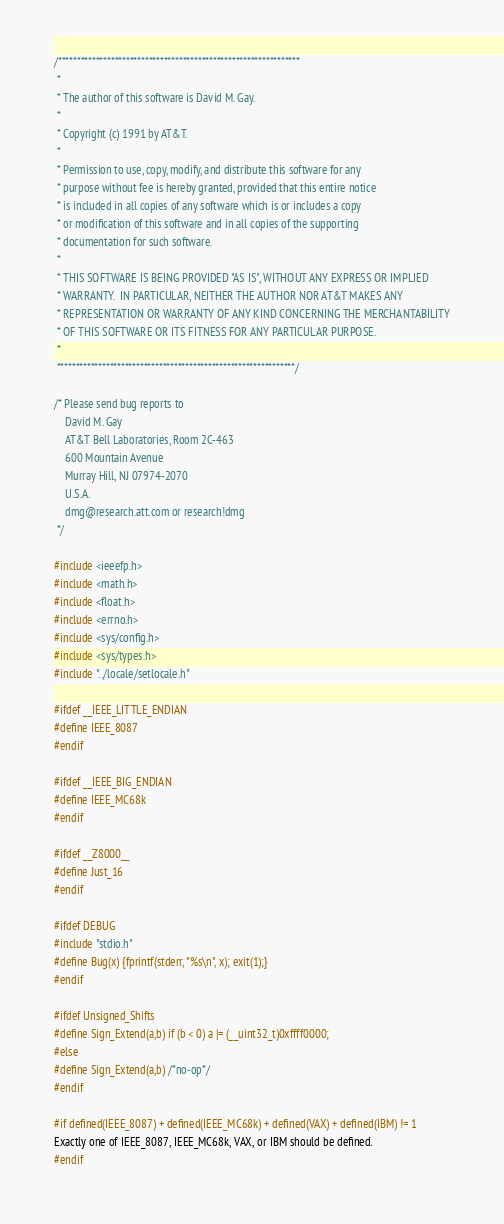<code> <loc_0><loc_0><loc_500><loc_500><_C_>/****************************************************************
 *
 * The author of this software is David M. Gay.
 *
 * Copyright (c) 1991 by AT&T.
 *
 * Permission to use, copy, modify, and distribute this software for any
 * purpose without fee is hereby granted, provided that this entire notice
 * is included in all copies of any software which is or includes a copy
 * or modification of this software and in all copies of the supporting
 * documentation for such software.
 *
 * THIS SOFTWARE IS BEING PROVIDED "AS IS", WITHOUT ANY EXPRESS OR IMPLIED
 * WARRANTY.  IN PARTICULAR, NEITHER THE AUTHOR NOR AT&T MAKES ANY
 * REPRESENTATION OR WARRANTY OF ANY KIND CONCERNING THE MERCHANTABILITY
 * OF THIS SOFTWARE OR ITS FITNESS FOR ANY PARTICULAR PURPOSE.
 *
 ***************************************************************/

/* Please send bug reports to
	David M. Gay
	AT&T Bell Laboratories, Room 2C-463
	600 Mountain Avenue
	Murray Hill, NJ 07974-2070
	U.S.A.
	dmg@research.att.com or research!dmg
 */

#include <ieeefp.h>
#include <math.h>
#include <float.h>
#include <errno.h>
#include <sys/config.h>
#include <sys/types.h>
#include "../locale/setlocale.h"

#ifdef __IEEE_LITTLE_ENDIAN
#define IEEE_8087
#endif

#ifdef __IEEE_BIG_ENDIAN
#define IEEE_MC68k
#endif

#ifdef __Z8000__
#define Just_16
#endif

#ifdef DEBUG
#include "stdio.h"
#define Bug(x) {fprintf(stderr, "%s\n", x); exit(1);}
#endif

#ifdef Unsigned_Shifts
#define Sign_Extend(a,b) if (b < 0) a |= (__uint32_t)0xffff0000;
#else
#define Sign_Extend(a,b) /*no-op*/
#endif

#if defined(IEEE_8087) + defined(IEEE_MC68k) + defined(VAX) + defined(IBM) != 1
Exactly one of IEEE_8087, IEEE_MC68k, VAX, or IBM should be defined.
#endif
</code> 